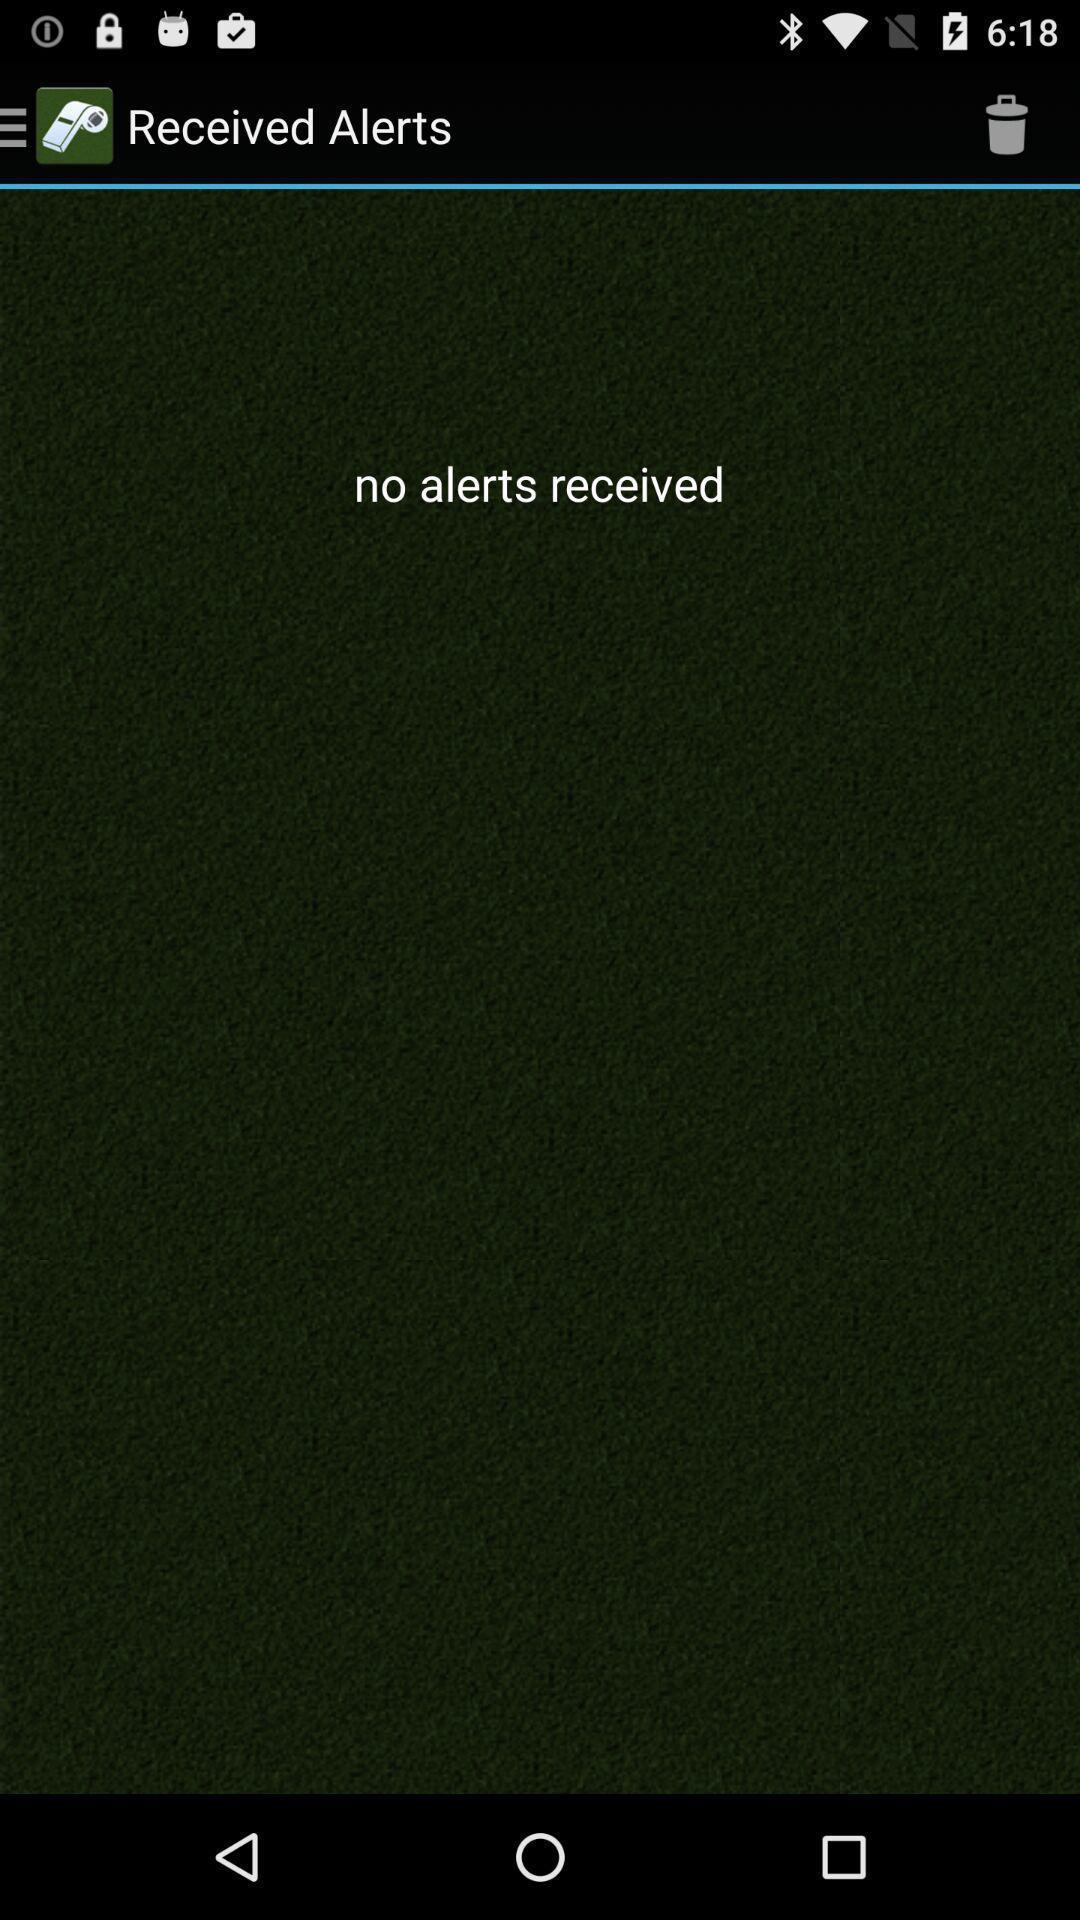What can you discern from this picture? Screen shows no received alerts. 